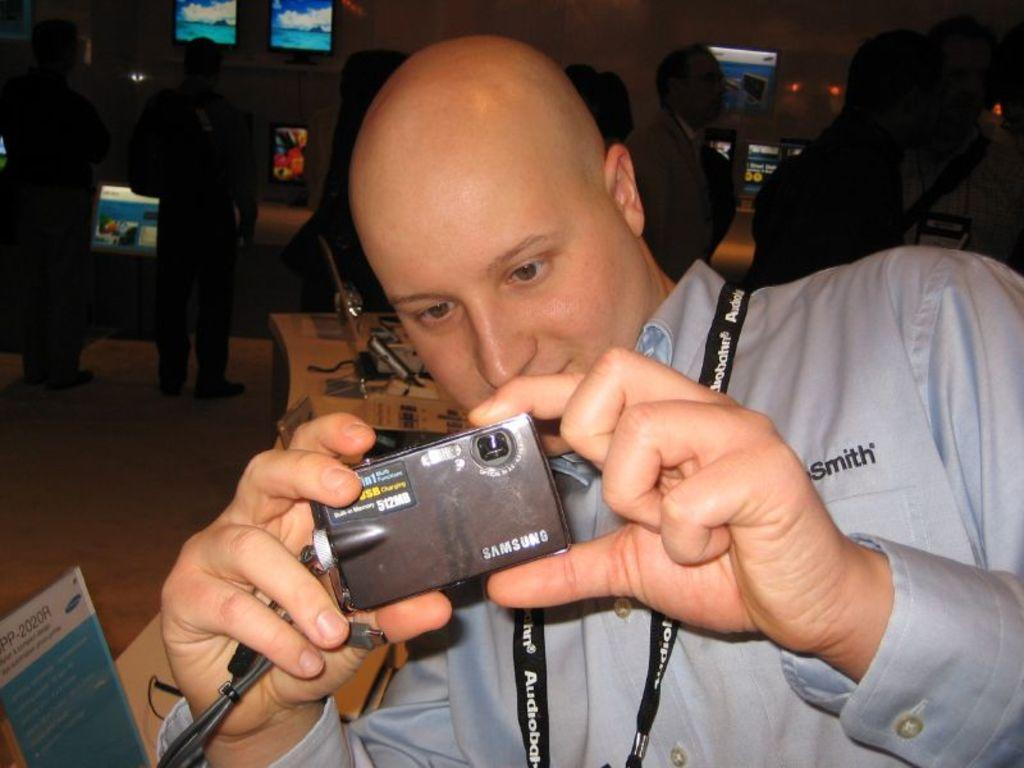Who is the main subject in the image? There is a man in the image. What is the man holding in the image? The man is holding a digital camera. What is the man doing with the digital camera? The man is taking a photo. What can be seen in the background of the image? There are people and televisions attached to the wall in the background. What is the name of the man's daughter in the image? There is no mention of a daughter in the image, so we cannot determine her name. 